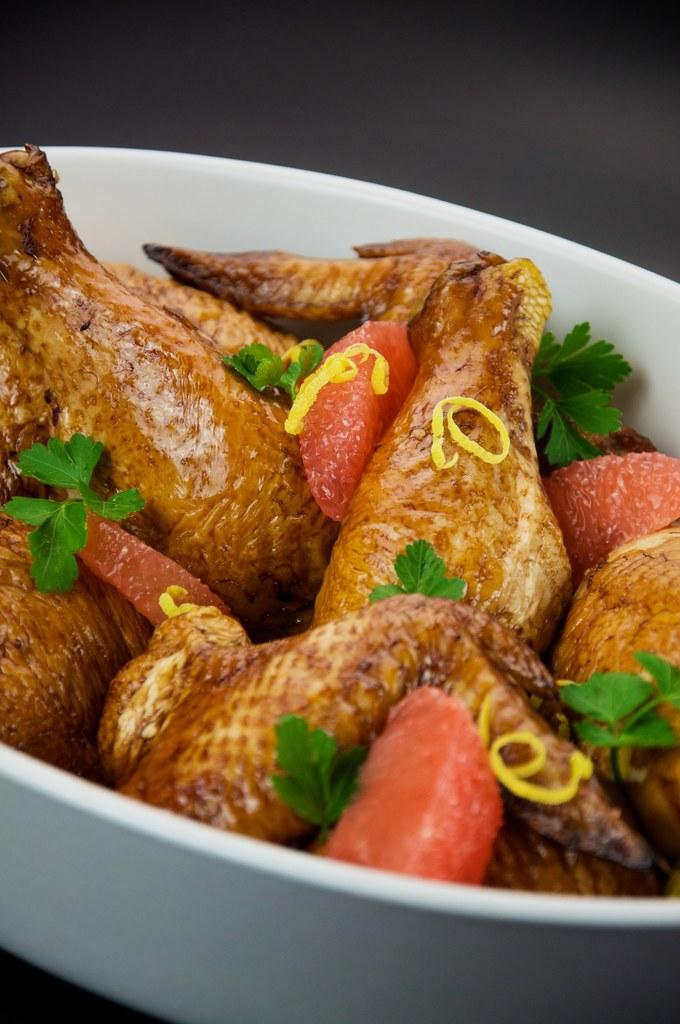What type of food is present in the image? There are chicken pieces and strawberries in the image. What herb can be seen in the image? Mint is present in the image. How are the food items and herb arranged in the image? They are in a bowl. What can be inferred about the lighting conditions in the image? The background of the image appears dark. What type of cord is visible in the image? There is no cord present in the image. What type of wood can be seen in the image? There is no wood present in the image. 